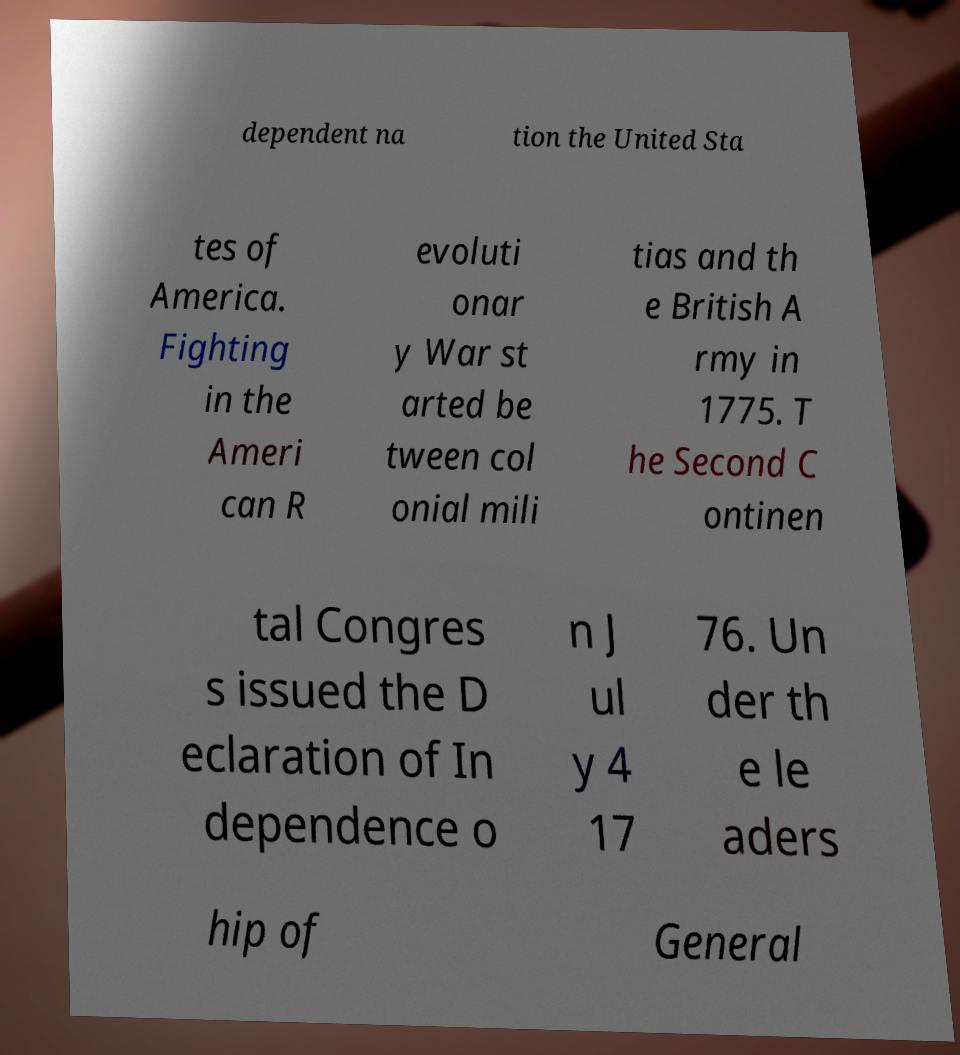Please identify and transcribe the text found in this image. dependent na tion the United Sta tes of America. Fighting in the Ameri can R evoluti onar y War st arted be tween col onial mili tias and th e British A rmy in 1775. T he Second C ontinen tal Congres s issued the D eclaration of In dependence o n J ul y 4 17 76. Un der th e le aders hip of General 